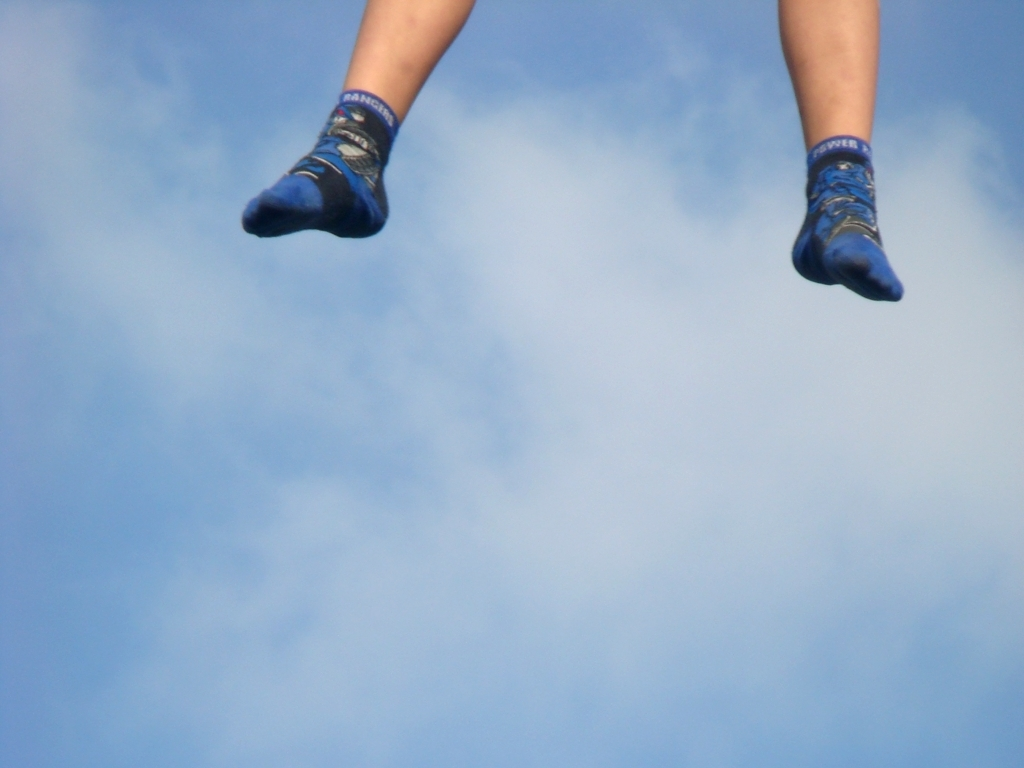What could be the mood of the person wearing these socks? While we cannot see the wearer, the context of the image—socks suspended in the air against a clear sky—evokes a sense of joy, carefree spirit, or excitement. The bright blue color of the socks and the seemingly vibrant pattern could suggest that the person has a playful or energetic disposition. 